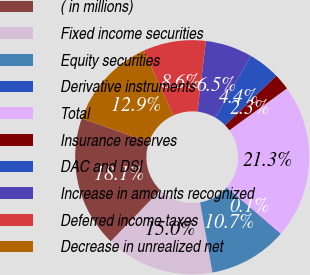<chart> <loc_0><loc_0><loc_500><loc_500><pie_chart><fcel>( in millions)<fcel>Fixed income securities<fcel>Equity securities<fcel>Derivative instruments<fcel>Total<fcel>Insurance reserves<fcel>DAC and DSI<fcel>Increase in amounts recognized<fcel>Deferred income taxes<fcel>Decrease in unrealized net<nl><fcel>18.14%<fcel>14.98%<fcel>10.74%<fcel>0.14%<fcel>21.34%<fcel>2.26%<fcel>4.38%<fcel>6.5%<fcel>8.62%<fcel>12.86%<nl></chart> 